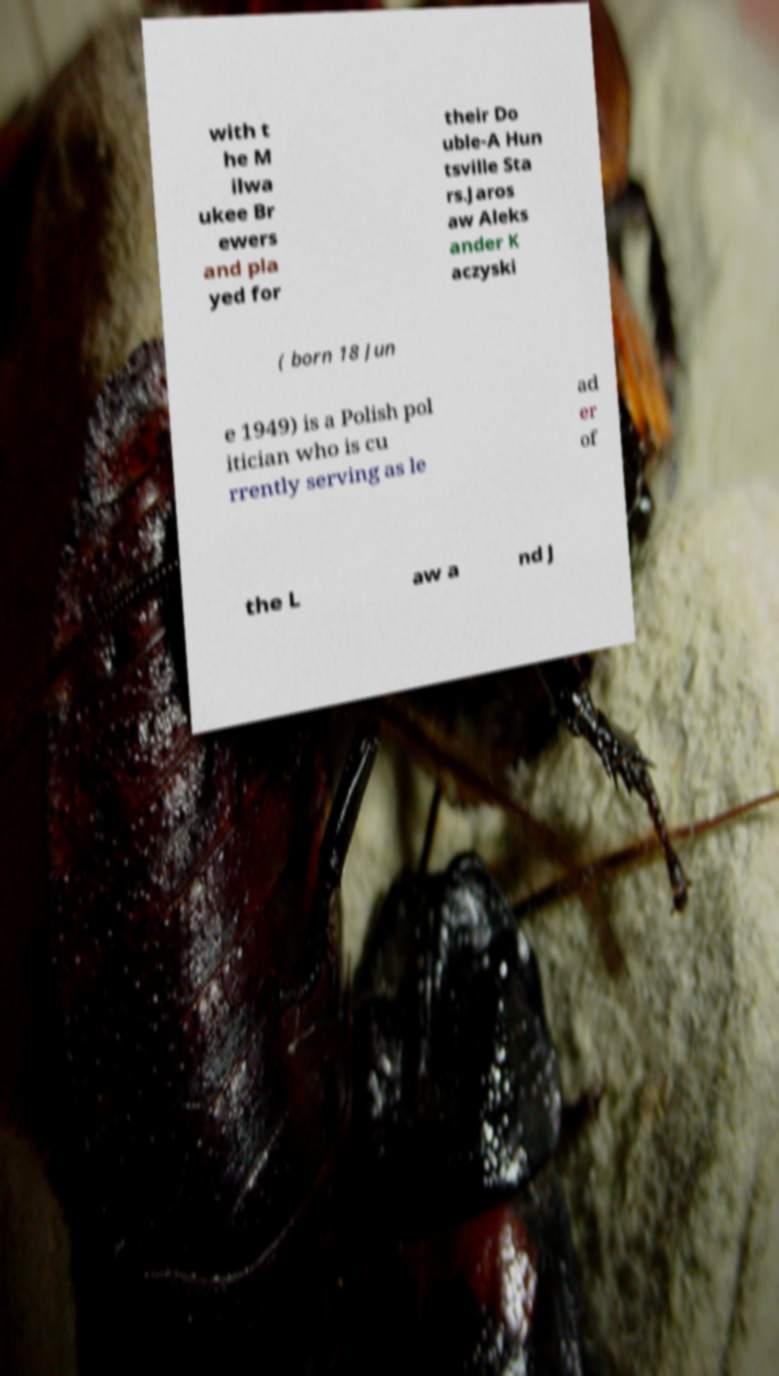Could you assist in decoding the text presented in this image and type it out clearly? with t he M ilwa ukee Br ewers and pla yed for their Do uble-A Hun tsville Sta rs.Jaros aw Aleks ander K aczyski ( born 18 Jun e 1949) is a Polish pol itician who is cu rrently serving as le ad er of the L aw a nd J 